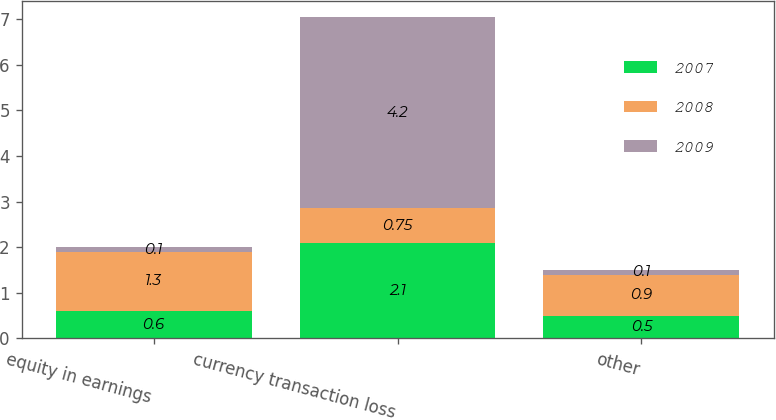<chart> <loc_0><loc_0><loc_500><loc_500><stacked_bar_chart><ecel><fcel>equity in earnings<fcel>currency transaction loss<fcel>other<nl><fcel>2007<fcel>0.6<fcel>2.1<fcel>0.5<nl><fcel>2008<fcel>1.3<fcel>0.75<fcel>0.9<nl><fcel>2009<fcel>0.1<fcel>4.2<fcel>0.1<nl></chart> 